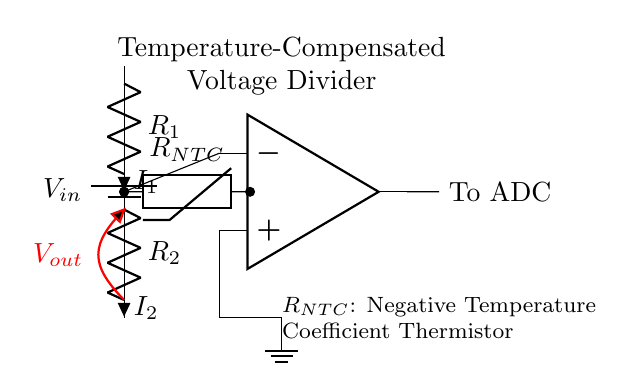What is the power supply voltage denoted as in the circuit? The power supply voltage is depicted as \( V_{in} \) in the circuit. It is the source that provides the energy necessary for the operation of the voltage divider.
Answer: \( V_{in} \) What type of thermistor is used in the circuit? The circuit uses a Negative Temperature Coefficient (NTC) thermistor, as indicated by the label \( R_{NTC} \). This type of thermistor decreases in resistance as the temperature increases.
Answer: NTC Thermistor What are the two resistances in the voltage divider? The circuit consists of two resistors identified as \( R_1 \) and \( R_2 \), which are essential for the operation of the voltage divider, providing a specific voltage drop across them.
Answer: \( R_1 \) and \( R_2 \) What is the purpose of the operational amplifier in this circuit? The operational amplifier is used to amplify the voltage \( V_{out} \) for better accuracy before it is sent to the ADC (Analog-to-Digital Converter). This amplification ensures that the ADC can read the voltage accurately.
Answer: Amplification What is the output voltage symbolized in the diagram? The output voltage is symbolized by \( V_{out} \), and it is the voltage measured across the lower resistor (or NTC thermistor) in the voltage divider configuration.
Answer: \( V_{out} \) How does the temperature affect the resistance of the NTC thermistor? The resistance of the NTC thermistor decreases as the temperature increases. This property is crucial for temperature compensation in the voltage sensing application of this circuit.
Answer: Decreases What is the main application of this voltage divider circuit? The main application is for accurate voltage sensing in weather monitoring stations, where the temperature changes need to be measured reliably.
Answer: Weather Monitoring 